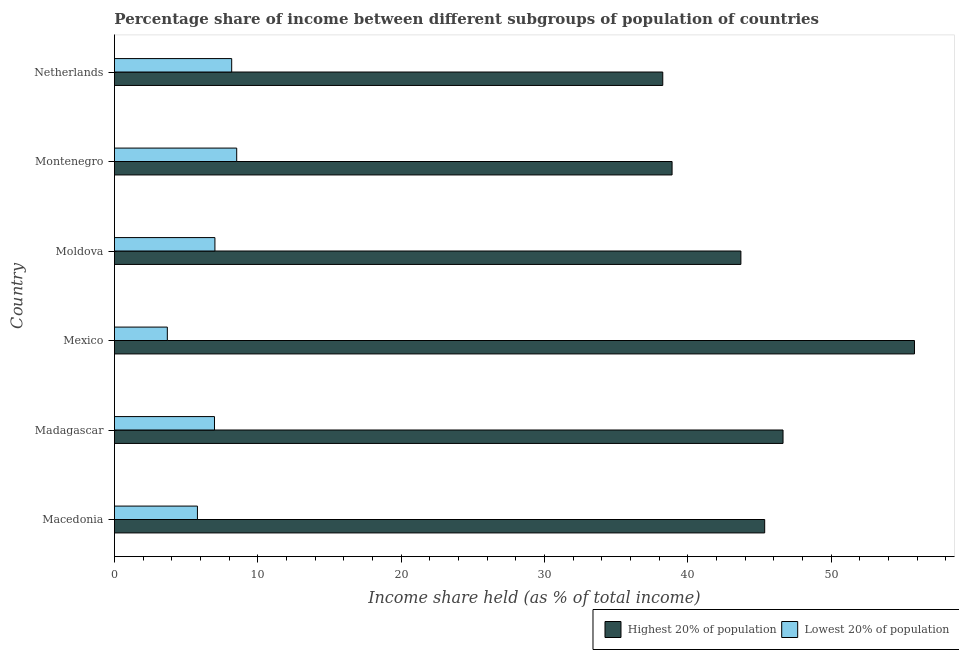How many groups of bars are there?
Offer a terse response. 6. Are the number of bars on each tick of the Y-axis equal?
Provide a short and direct response. Yes. How many bars are there on the 3rd tick from the top?
Give a very brief answer. 2. How many bars are there on the 2nd tick from the bottom?
Provide a short and direct response. 2. What is the label of the 5th group of bars from the top?
Offer a terse response. Madagascar. What is the income share held by lowest 20% of the population in Macedonia?
Provide a succinct answer. 5.79. Across all countries, what is the maximum income share held by lowest 20% of the population?
Keep it short and to the point. 8.53. Across all countries, what is the minimum income share held by lowest 20% of the population?
Provide a short and direct response. 3.69. In which country was the income share held by highest 20% of the population maximum?
Your answer should be very brief. Mexico. In which country was the income share held by highest 20% of the population minimum?
Give a very brief answer. Netherlands. What is the total income share held by lowest 20% of the population in the graph?
Give a very brief answer. 40.18. What is the difference between the income share held by highest 20% of the population in Macedonia and that in Madagascar?
Offer a terse response. -1.28. What is the difference between the income share held by highest 20% of the population in Moldova and the income share held by lowest 20% of the population in Montenegro?
Offer a very short reply. 35.17. What is the average income share held by highest 20% of the population per country?
Provide a short and direct response. 44.78. What is the difference between the income share held by lowest 20% of the population and income share held by highest 20% of the population in Macedonia?
Your answer should be compact. -39.57. What is the ratio of the income share held by lowest 20% of the population in Mexico to that in Netherlands?
Offer a terse response. 0.45. What is the difference between the highest and the lowest income share held by highest 20% of the population?
Offer a terse response. 17.56. Is the sum of the income share held by highest 20% of the population in Moldova and Montenegro greater than the maximum income share held by lowest 20% of the population across all countries?
Give a very brief answer. Yes. What does the 2nd bar from the top in Mexico represents?
Provide a short and direct response. Highest 20% of population. What does the 1st bar from the bottom in Madagascar represents?
Your answer should be very brief. Highest 20% of population. How many bars are there?
Your answer should be very brief. 12. What is the difference between two consecutive major ticks on the X-axis?
Your answer should be compact. 10. Are the values on the major ticks of X-axis written in scientific E-notation?
Make the answer very short. No. How many legend labels are there?
Your answer should be very brief. 2. What is the title of the graph?
Your response must be concise. Percentage share of income between different subgroups of population of countries. What is the label or title of the X-axis?
Keep it short and to the point. Income share held (as % of total income). What is the Income share held (as % of total income) in Highest 20% of population in Macedonia?
Your response must be concise. 45.36. What is the Income share held (as % of total income) of Lowest 20% of population in Macedonia?
Offer a terse response. 5.79. What is the Income share held (as % of total income) in Highest 20% of population in Madagascar?
Keep it short and to the point. 46.64. What is the Income share held (as % of total income) of Lowest 20% of population in Madagascar?
Keep it short and to the point. 6.98. What is the Income share held (as % of total income) of Highest 20% of population in Mexico?
Provide a short and direct response. 55.81. What is the Income share held (as % of total income) of Lowest 20% of population in Mexico?
Make the answer very short. 3.69. What is the Income share held (as % of total income) of Highest 20% of population in Moldova?
Ensure brevity in your answer.  43.7. What is the Income share held (as % of total income) in Lowest 20% of population in Moldova?
Ensure brevity in your answer.  7.01. What is the Income share held (as % of total income) of Highest 20% of population in Montenegro?
Give a very brief answer. 38.9. What is the Income share held (as % of total income) in Lowest 20% of population in Montenegro?
Your response must be concise. 8.53. What is the Income share held (as % of total income) of Highest 20% of population in Netherlands?
Your answer should be very brief. 38.25. What is the Income share held (as % of total income) in Lowest 20% of population in Netherlands?
Make the answer very short. 8.18. Across all countries, what is the maximum Income share held (as % of total income) in Highest 20% of population?
Provide a short and direct response. 55.81. Across all countries, what is the maximum Income share held (as % of total income) of Lowest 20% of population?
Provide a short and direct response. 8.53. Across all countries, what is the minimum Income share held (as % of total income) in Highest 20% of population?
Ensure brevity in your answer.  38.25. Across all countries, what is the minimum Income share held (as % of total income) in Lowest 20% of population?
Offer a terse response. 3.69. What is the total Income share held (as % of total income) in Highest 20% of population in the graph?
Your answer should be compact. 268.66. What is the total Income share held (as % of total income) in Lowest 20% of population in the graph?
Your response must be concise. 40.18. What is the difference between the Income share held (as % of total income) in Highest 20% of population in Macedonia and that in Madagascar?
Offer a very short reply. -1.28. What is the difference between the Income share held (as % of total income) of Lowest 20% of population in Macedonia and that in Madagascar?
Your answer should be very brief. -1.19. What is the difference between the Income share held (as % of total income) of Highest 20% of population in Macedonia and that in Mexico?
Your response must be concise. -10.45. What is the difference between the Income share held (as % of total income) of Highest 20% of population in Macedonia and that in Moldova?
Provide a short and direct response. 1.66. What is the difference between the Income share held (as % of total income) in Lowest 20% of population in Macedonia and that in Moldova?
Ensure brevity in your answer.  -1.22. What is the difference between the Income share held (as % of total income) in Highest 20% of population in Macedonia and that in Montenegro?
Offer a very short reply. 6.46. What is the difference between the Income share held (as % of total income) in Lowest 20% of population in Macedonia and that in Montenegro?
Your answer should be very brief. -2.74. What is the difference between the Income share held (as % of total income) of Highest 20% of population in Macedonia and that in Netherlands?
Keep it short and to the point. 7.11. What is the difference between the Income share held (as % of total income) of Lowest 20% of population in Macedonia and that in Netherlands?
Provide a succinct answer. -2.39. What is the difference between the Income share held (as % of total income) in Highest 20% of population in Madagascar and that in Mexico?
Your response must be concise. -9.17. What is the difference between the Income share held (as % of total income) of Lowest 20% of population in Madagascar and that in Mexico?
Provide a succinct answer. 3.29. What is the difference between the Income share held (as % of total income) in Highest 20% of population in Madagascar and that in Moldova?
Give a very brief answer. 2.94. What is the difference between the Income share held (as % of total income) of Lowest 20% of population in Madagascar and that in Moldova?
Provide a short and direct response. -0.03. What is the difference between the Income share held (as % of total income) of Highest 20% of population in Madagascar and that in Montenegro?
Offer a terse response. 7.74. What is the difference between the Income share held (as % of total income) in Lowest 20% of population in Madagascar and that in Montenegro?
Your response must be concise. -1.55. What is the difference between the Income share held (as % of total income) of Highest 20% of population in Madagascar and that in Netherlands?
Make the answer very short. 8.39. What is the difference between the Income share held (as % of total income) of Lowest 20% of population in Madagascar and that in Netherlands?
Offer a very short reply. -1.2. What is the difference between the Income share held (as % of total income) in Highest 20% of population in Mexico and that in Moldova?
Give a very brief answer. 12.11. What is the difference between the Income share held (as % of total income) of Lowest 20% of population in Mexico and that in Moldova?
Your answer should be very brief. -3.32. What is the difference between the Income share held (as % of total income) in Highest 20% of population in Mexico and that in Montenegro?
Your answer should be very brief. 16.91. What is the difference between the Income share held (as % of total income) in Lowest 20% of population in Mexico and that in Montenegro?
Provide a succinct answer. -4.84. What is the difference between the Income share held (as % of total income) of Highest 20% of population in Mexico and that in Netherlands?
Make the answer very short. 17.56. What is the difference between the Income share held (as % of total income) of Lowest 20% of population in Mexico and that in Netherlands?
Your answer should be compact. -4.49. What is the difference between the Income share held (as % of total income) in Lowest 20% of population in Moldova and that in Montenegro?
Offer a terse response. -1.52. What is the difference between the Income share held (as % of total income) of Highest 20% of population in Moldova and that in Netherlands?
Offer a terse response. 5.45. What is the difference between the Income share held (as % of total income) of Lowest 20% of population in Moldova and that in Netherlands?
Keep it short and to the point. -1.17. What is the difference between the Income share held (as % of total income) in Highest 20% of population in Montenegro and that in Netherlands?
Give a very brief answer. 0.65. What is the difference between the Income share held (as % of total income) in Highest 20% of population in Macedonia and the Income share held (as % of total income) in Lowest 20% of population in Madagascar?
Offer a very short reply. 38.38. What is the difference between the Income share held (as % of total income) in Highest 20% of population in Macedonia and the Income share held (as % of total income) in Lowest 20% of population in Mexico?
Provide a succinct answer. 41.67. What is the difference between the Income share held (as % of total income) of Highest 20% of population in Macedonia and the Income share held (as % of total income) of Lowest 20% of population in Moldova?
Offer a very short reply. 38.35. What is the difference between the Income share held (as % of total income) in Highest 20% of population in Macedonia and the Income share held (as % of total income) in Lowest 20% of population in Montenegro?
Offer a terse response. 36.83. What is the difference between the Income share held (as % of total income) of Highest 20% of population in Macedonia and the Income share held (as % of total income) of Lowest 20% of population in Netherlands?
Provide a short and direct response. 37.18. What is the difference between the Income share held (as % of total income) in Highest 20% of population in Madagascar and the Income share held (as % of total income) in Lowest 20% of population in Mexico?
Provide a short and direct response. 42.95. What is the difference between the Income share held (as % of total income) in Highest 20% of population in Madagascar and the Income share held (as % of total income) in Lowest 20% of population in Moldova?
Provide a succinct answer. 39.63. What is the difference between the Income share held (as % of total income) of Highest 20% of population in Madagascar and the Income share held (as % of total income) of Lowest 20% of population in Montenegro?
Your answer should be compact. 38.11. What is the difference between the Income share held (as % of total income) of Highest 20% of population in Madagascar and the Income share held (as % of total income) of Lowest 20% of population in Netherlands?
Your answer should be very brief. 38.46. What is the difference between the Income share held (as % of total income) of Highest 20% of population in Mexico and the Income share held (as % of total income) of Lowest 20% of population in Moldova?
Provide a short and direct response. 48.8. What is the difference between the Income share held (as % of total income) of Highest 20% of population in Mexico and the Income share held (as % of total income) of Lowest 20% of population in Montenegro?
Ensure brevity in your answer.  47.28. What is the difference between the Income share held (as % of total income) in Highest 20% of population in Mexico and the Income share held (as % of total income) in Lowest 20% of population in Netherlands?
Offer a very short reply. 47.63. What is the difference between the Income share held (as % of total income) in Highest 20% of population in Moldova and the Income share held (as % of total income) in Lowest 20% of population in Montenegro?
Offer a terse response. 35.17. What is the difference between the Income share held (as % of total income) in Highest 20% of population in Moldova and the Income share held (as % of total income) in Lowest 20% of population in Netherlands?
Your response must be concise. 35.52. What is the difference between the Income share held (as % of total income) of Highest 20% of population in Montenegro and the Income share held (as % of total income) of Lowest 20% of population in Netherlands?
Your answer should be very brief. 30.72. What is the average Income share held (as % of total income) of Highest 20% of population per country?
Provide a short and direct response. 44.78. What is the average Income share held (as % of total income) in Lowest 20% of population per country?
Offer a very short reply. 6.7. What is the difference between the Income share held (as % of total income) of Highest 20% of population and Income share held (as % of total income) of Lowest 20% of population in Macedonia?
Provide a succinct answer. 39.57. What is the difference between the Income share held (as % of total income) of Highest 20% of population and Income share held (as % of total income) of Lowest 20% of population in Madagascar?
Give a very brief answer. 39.66. What is the difference between the Income share held (as % of total income) of Highest 20% of population and Income share held (as % of total income) of Lowest 20% of population in Mexico?
Provide a succinct answer. 52.12. What is the difference between the Income share held (as % of total income) of Highest 20% of population and Income share held (as % of total income) of Lowest 20% of population in Moldova?
Provide a short and direct response. 36.69. What is the difference between the Income share held (as % of total income) in Highest 20% of population and Income share held (as % of total income) in Lowest 20% of population in Montenegro?
Make the answer very short. 30.37. What is the difference between the Income share held (as % of total income) in Highest 20% of population and Income share held (as % of total income) in Lowest 20% of population in Netherlands?
Ensure brevity in your answer.  30.07. What is the ratio of the Income share held (as % of total income) of Highest 20% of population in Macedonia to that in Madagascar?
Your answer should be compact. 0.97. What is the ratio of the Income share held (as % of total income) in Lowest 20% of population in Macedonia to that in Madagascar?
Your answer should be compact. 0.83. What is the ratio of the Income share held (as % of total income) of Highest 20% of population in Macedonia to that in Mexico?
Give a very brief answer. 0.81. What is the ratio of the Income share held (as % of total income) in Lowest 20% of population in Macedonia to that in Mexico?
Make the answer very short. 1.57. What is the ratio of the Income share held (as % of total income) of Highest 20% of population in Macedonia to that in Moldova?
Provide a short and direct response. 1.04. What is the ratio of the Income share held (as % of total income) in Lowest 20% of population in Macedonia to that in Moldova?
Give a very brief answer. 0.83. What is the ratio of the Income share held (as % of total income) of Highest 20% of population in Macedonia to that in Montenegro?
Give a very brief answer. 1.17. What is the ratio of the Income share held (as % of total income) of Lowest 20% of population in Macedonia to that in Montenegro?
Your response must be concise. 0.68. What is the ratio of the Income share held (as % of total income) in Highest 20% of population in Macedonia to that in Netherlands?
Your answer should be compact. 1.19. What is the ratio of the Income share held (as % of total income) in Lowest 20% of population in Macedonia to that in Netherlands?
Keep it short and to the point. 0.71. What is the ratio of the Income share held (as % of total income) of Highest 20% of population in Madagascar to that in Mexico?
Your answer should be compact. 0.84. What is the ratio of the Income share held (as % of total income) of Lowest 20% of population in Madagascar to that in Mexico?
Ensure brevity in your answer.  1.89. What is the ratio of the Income share held (as % of total income) in Highest 20% of population in Madagascar to that in Moldova?
Your response must be concise. 1.07. What is the ratio of the Income share held (as % of total income) of Lowest 20% of population in Madagascar to that in Moldova?
Your response must be concise. 1. What is the ratio of the Income share held (as % of total income) of Highest 20% of population in Madagascar to that in Montenegro?
Offer a very short reply. 1.2. What is the ratio of the Income share held (as % of total income) in Lowest 20% of population in Madagascar to that in Montenegro?
Make the answer very short. 0.82. What is the ratio of the Income share held (as % of total income) in Highest 20% of population in Madagascar to that in Netherlands?
Offer a terse response. 1.22. What is the ratio of the Income share held (as % of total income) of Lowest 20% of population in Madagascar to that in Netherlands?
Give a very brief answer. 0.85. What is the ratio of the Income share held (as % of total income) of Highest 20% of population in Mexico to that in Moldova?
Offer a very short reply. 1.28. What is the ratio of the Income share held (as % of total income) of Lowest 20% of population in Mexico to that in Moldova?
Provide a succinct answer. 0.53. What is the ratio of the Income share held (as % of total income) of Highest 20% of population in Mexico to that in Montenegro?
Provide a succinct answer. 1.43. What is the ratio of the Income share held (as % of total income) in Lowest 20% of population in Mexico to that in Montenegro?
Offer a very short reply. 0.43. What is the ratio of the Income share held (as % of total income) in Highest 20% of population in Mexico to that in Netherlands?
Provide a succinct answer. 1.46. What is the ratio of the Income share held (as % of total income) in Lowest 20% of population in Mexico to that in Netherlands?
Offer a terse response. 0.45. What is the ratio of the Income share held (as % of total income) of Highest 20% of population in Moldova to that in Montenegro?
Ensure brevity in your answer.  1.12. What is the ratio of the Income share held (as % of total income) in Lowest 20% of population in Moldova to that in Montenegro?
Make the answer very short. 0.82. What is the ratio of the Income share held (as % of total income) of Highest 20% of population in Moldova to that in Netherlands?
Provide a short and direct response. 1.14. What is the ratio of the Income share held (as % of total income) of Lowest 20% of population in Moldova to that in Netherlands?
Offer a very short reply. 0.86. What is the ratio of the Income share held (as % of total income) in Highest 20% of population in Montenegro to that in Netherlands?
Keep it short and to the point. 1.02. What is the ratio of the Income share held (as % of total income) in Lowest 20% of population in Montenegro to that in Netherlands?
Keep it short and to the point. 1.04. What is the difference between the highest and the second highest Income share held (as % of total income) of Highest 20% of population?
Your response must be concise. 9.17. What is the difference between the highest and the second highest Income share held (as % of total income) in Lowest 20% of population?
Make the answer very short. 0.35. What is the difference between the highest and the lowest Income share held (as % of total income) in Highest 20% of population?
Offer a very short reply. 17.56. What is the difference between the highest and the lowest Income share held (as % of total income) of Lowest 20% of population?
Keep it short and to the point. 4.84. 